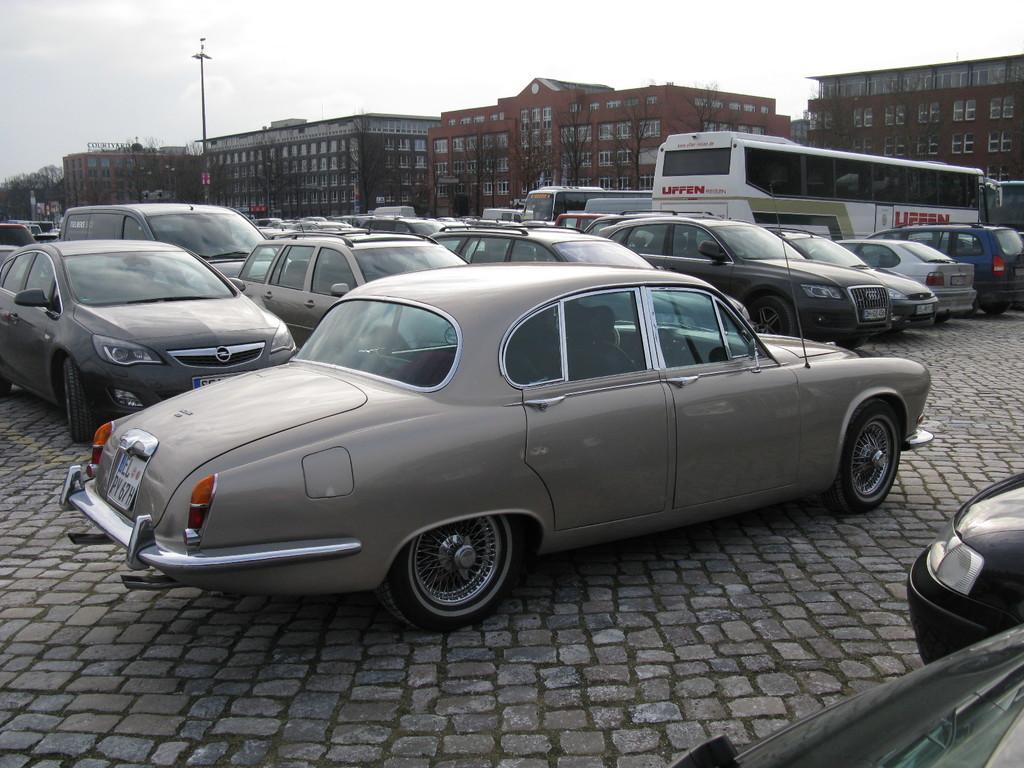Can you describe this image briefly? In this image we can see so many cars and buses are parked, behind buildings are there and one pole is present. The sky is full of cloud. 